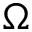<formula> <loc_0><loc_0><loc_500><loc_500>\Omega</formula> 